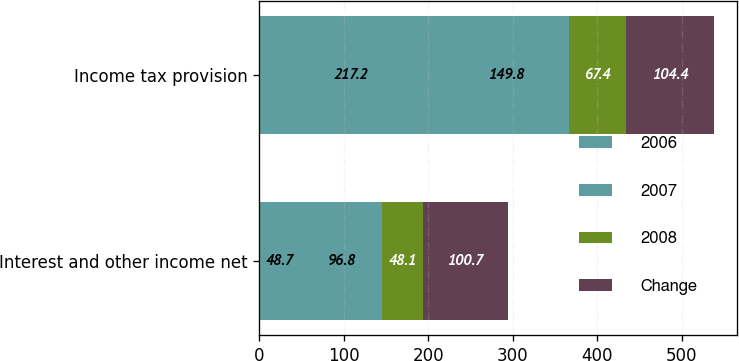Convert chart. <chart><loc_0><loc_0><loc_500><loc_500><stacked_bar_chart><ecel><fcel>Interest and other income net<fcel>Income tax provision<nl><fcel>2006<fcel>48.7<fcel>217.2<nl><fcel>2007<fcel>96.8<fcel>149.8<nl><fcel>2008<fcel>48.1<fcel>67.4<nl><fcel>Change<fcel>100.7<fcel>104.4<nl></chart> 